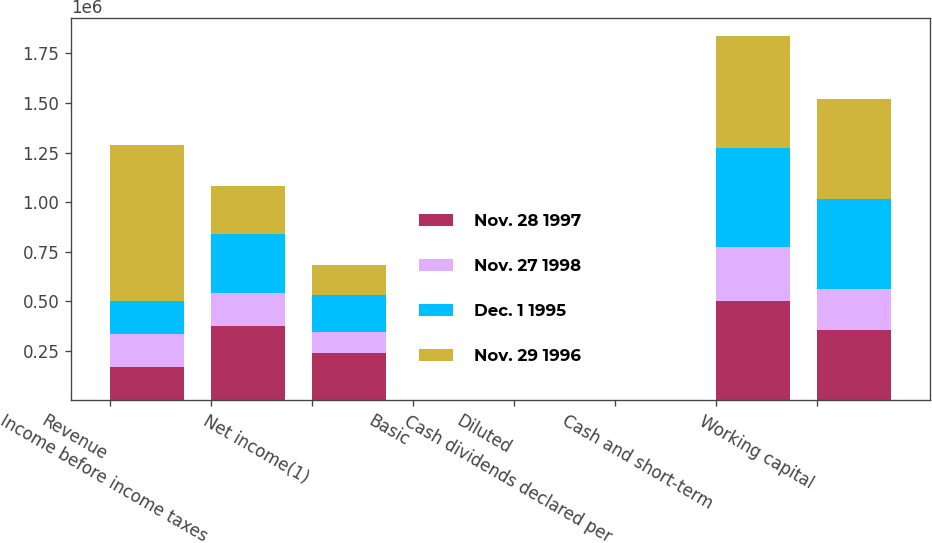Convert chart to OTSL. <chart><loc_0><loc_0><loc_500><loc_500><stacked_bar_chart><ecel><fcel>Revenue<fcel>Income before income taxes<fcel>Net income(1)<fcel>Basic<fcel>Diluted<fcel>Cash dividends declared per<fcel>Cash and short-term<fcel>Working capital<nl><fcel>Nov. 28 1997<fcel>167694<fcel>374427<fcel>237751<fcel>1.97<fcel>1.84<fcel>0.1<fcel>498716<fcel>355386<nl><fcel>Nov. 27 1998<fcel>167694<fcel>167694<fcel>105144<fcel>0.79<fcel>0.77<fcel>0.1<fcel>272547<fcel>204979<nl><fcel>Dec. 1 1995<fcel>167694<fcel>296090<fcel>186837<fcel>1.3<fcel>1.26<fcel>0.1<fcel>502956<fcel>454299<nl><fcel>Nov. 29 1996<fcel>786563<fcel>244824<fcel>153277<fcel>1.06<fcel>1.02<fcel>0.1<fcel>564116<fcel>506092<nl></chart> 